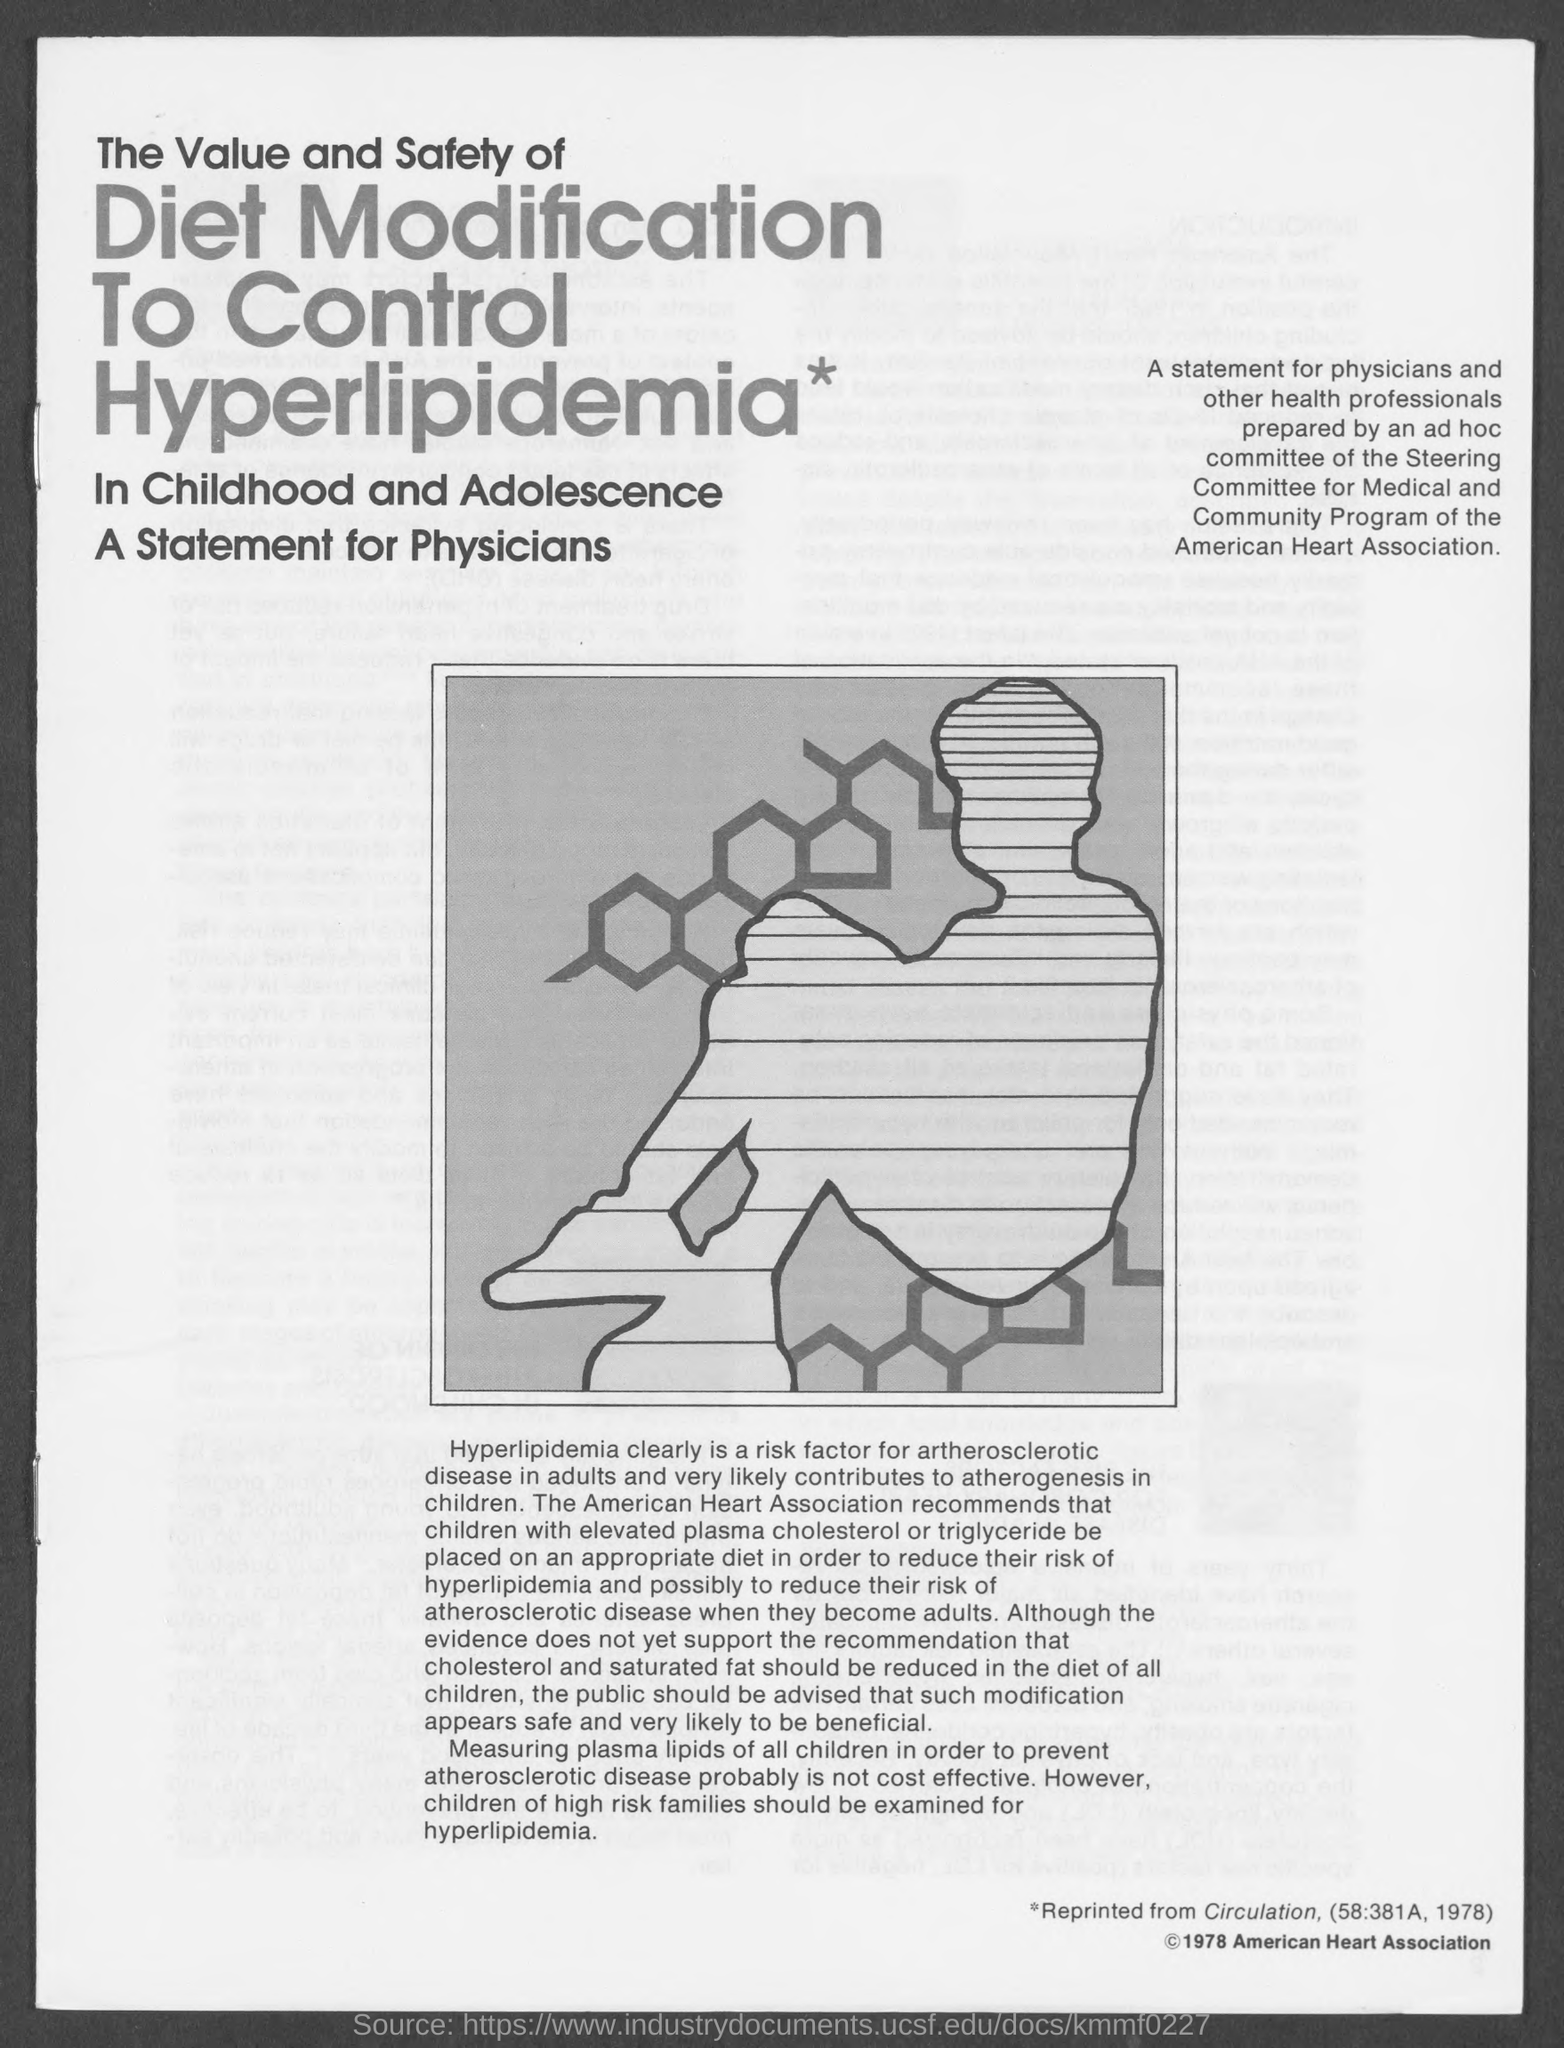What is the name of heart association ?
Your response must be concise. American Heart Association. 